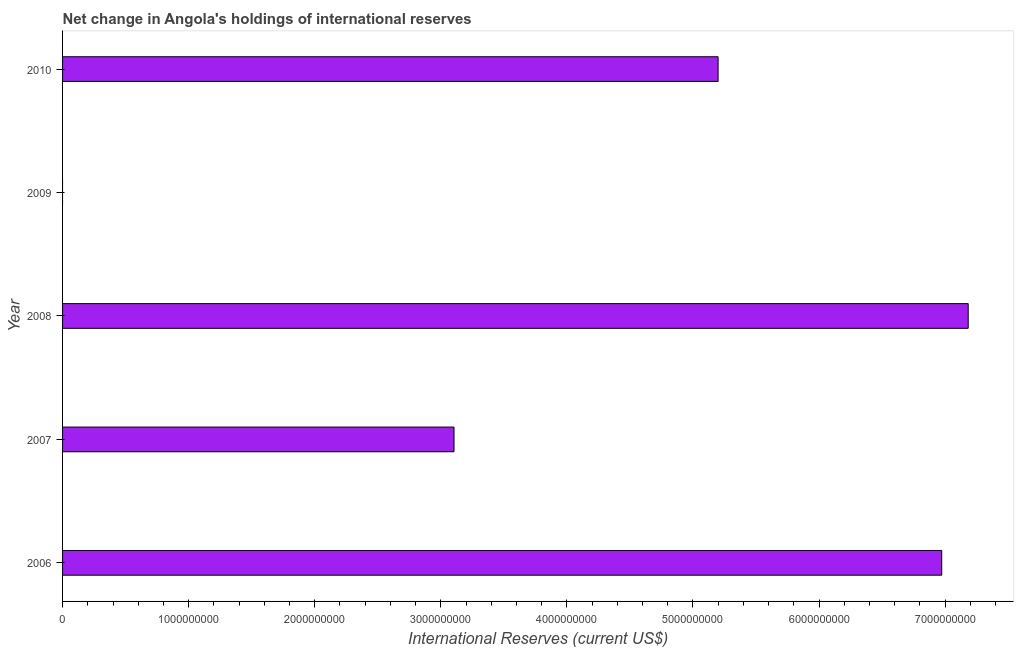Does the graph contain any zero values?
Your answer should be very brief. Yes. Does the graph contain grids?
Make the answer very short. No. What is the title of the graph?
Provide a succinct answer. Net change in Angola's holdings of international reserves. What is the label or title of the X-axis?
Offer a terse response. International Reserves (current US$). What is the label or title of the Y-axis?
Offer a very short reply. Year. What is the reserves and related items in 2009?
Provide a succinct answer. 0. Across all years, what is the maximum reserves and related items?
Offer a very short reply. 7.18e+09. What is the sum of the reserves and related items?
Your response must be concise. 2.25e+1. What is the difference between the reserves and related items in 2006 and 2007?
Provide a short and direct response. 3.87e+09. What is the average reserves and related items per year?
Provide a succinct answer. 4.49e+09. What is the median reserves and related items?
Keep it short and to the point. 5.20e+09. What is the ratio of the reserves and related items in 2008 to that in 2010?
Offer a very short reply. 1.38. Is the reserves and related items in 2006 less than that in 2008?
Make the answer very short. Yes. What is the difference between the highest and the second highest reserves and related items?
Give a very brief answer. 2.10e+08. What is the difference between the highest and the lowest reserves and related items?
Offer a very short reply. 7.18e+09. In how many years, is the reserves and related items greater than the average reserves and related items taken over all years?
Provide a short and direct response. 3. How many bars are there?
Make the answer very short. 4. What is the International Reserves (current US$) in 2006?
Offer a terse response. 6.97e+09. What is the International Reserves (current US$) of 2007?
Make the answer very short. 3.10e+09. What is the International Reserves (current US$) in 2008?
Give a very brief answer. 7.18e+09. What is the International Reserves (current US$) in 2010?
Your response must be concise. 5.20e+09. What is the difference between the International Reserves (current US$) in 2006 and 2007?
Make the answer very short. 3.87e+09. What is the difference between the International Reserves (current US$) in 2006 and 2008?
Keep it short and to the point. -2.10e+08. What is the difference between the International Reserves (current US$) in 2006 and 2010?
Make the answer very short. 1.77e+09. What is the difference between the International Reserves (current US$) in 2007 and 2008?
Offer a terse response. -4.08e+09. What is the difference between the International Reserves (current US$) in 2007 and 2010?
Make the answer very short. -2.09e+09. What is the difference between the International Reserves (current US$) in 2008 and 2010?
Offer a terse response. 1.98e+09. What is the ratio of the International Reserves (current US$) in 2006 to that in 2007?
Your answer should be very brief. 2.25. What is the ratio of the International Reserves (current US$) in 2006 to that in 2010?
Make the answer very short. 1.34. What is the ratio of the International Reserves (current US$) in 2007 to that in 2008?
Your answer should be compact. 0.43. What is the ratio of the International Reserves (current US$) in 2007 to that in 2010?
Give a very brief answer. 0.6. What is the ratio of the International Reserves (current US$) in 2008 to that in 2010?
Offer a very short reply. 1.38. 